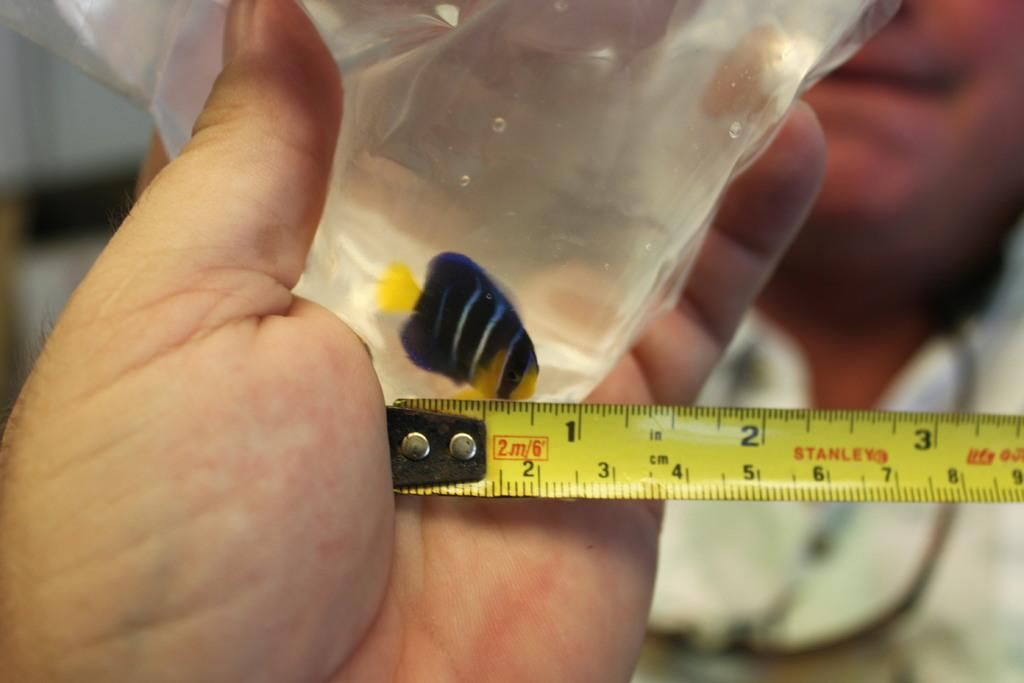<image>
Describe the image concisely. Someone is measuring a tropical fish in a bag, and they're using a Stanley brand measuring tape. 